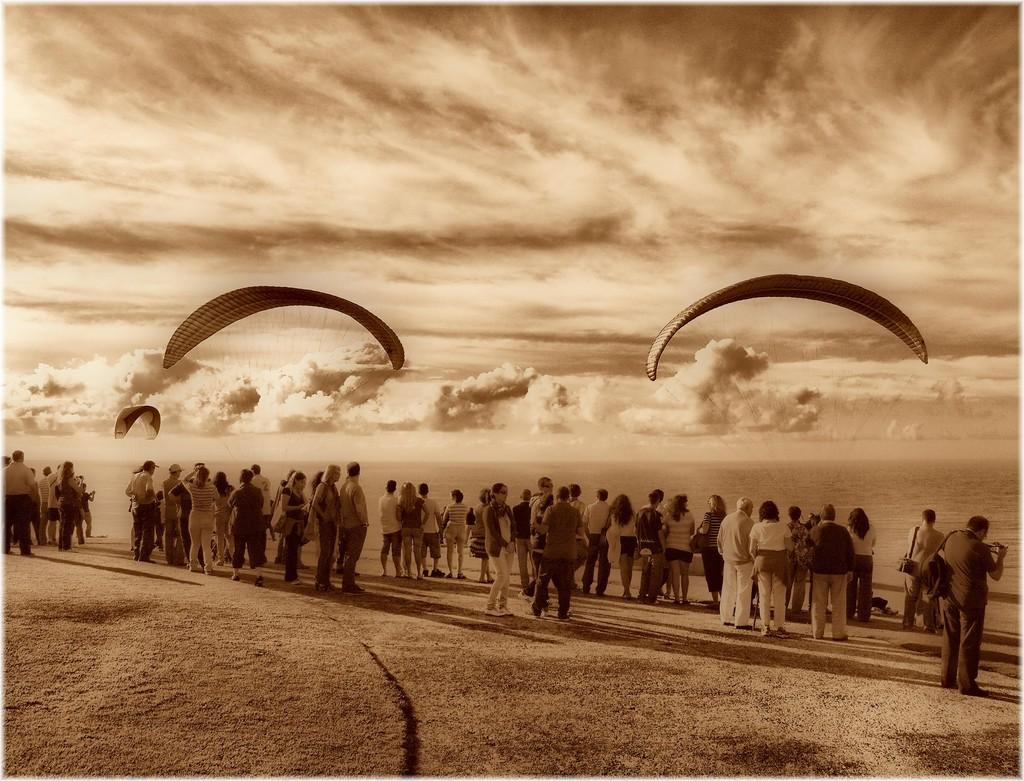What is happening in the front of the image? There are many people standing in the front of the image. What is the color scheme of the image? The image is in black and white. What can be seen in the sky in the image? There are parachutes in the sky. How would you describe the sky in the image? The sky is filled with clouds. What type of rhythm can be heard coming from the pipe in the image? There is no pipe present in the image, so it is not possible to determine the rhythm. 